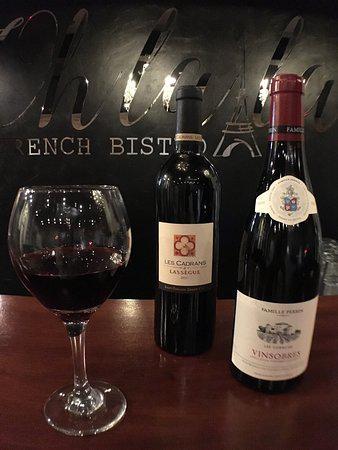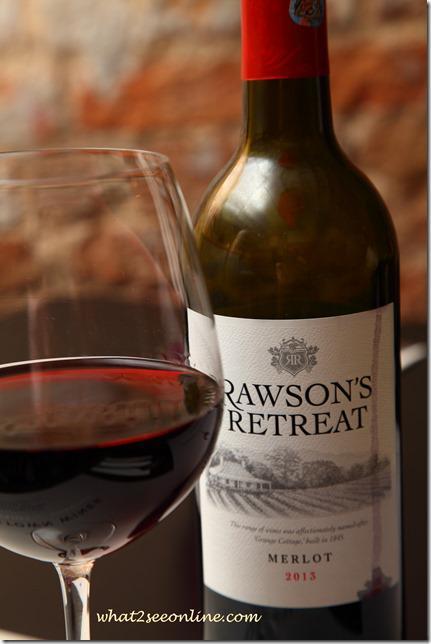The first image is the image on the left, the second image is the image on the right. Evaluate the accuracy of this statement regarding the images: "In one of the images there are two wine bottles next to each other.". Is it true? Answer yes or no. Yes. 